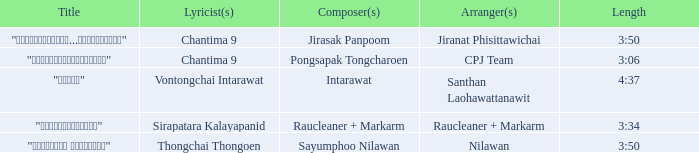Who was the composer of "ขอโทษ"? Intarawat. Give me the full table as a dictionary. {'header': ['Title', 'Lyricist(s)', 'Composer(s)', 'Arranger(s)', 'Length'], 'rows': [['"เรายังรักกัน...ไม่ใช่เหรอ"', 'Chantima 9', 'Jirasak Panpoom', 'Jiranat Phisittawichai', '3:50'], ['"นางฟ้าตาชั้นเดียว"', 'Chantima 9', 'Pongsapak Tongcharoen', 'CPJ Team', '3:06'], ['"ขอโทษ"', 'Vontongchai Intarawat', 'Intarawat', 'Santhan Laohawattanawit', '4:37'], ['"แค่อยากให้รู้"', 'Sirapatara Kalayapanid', 'Raucleaner + Markarm', 'Raucleaner + Markarm', '3:34'], ['"เลือกลืม เลือกจำ"', 'Thongchai Thongoen', 'Sayumphoo Nilawan', 'Nilawan', '3:50']]} 